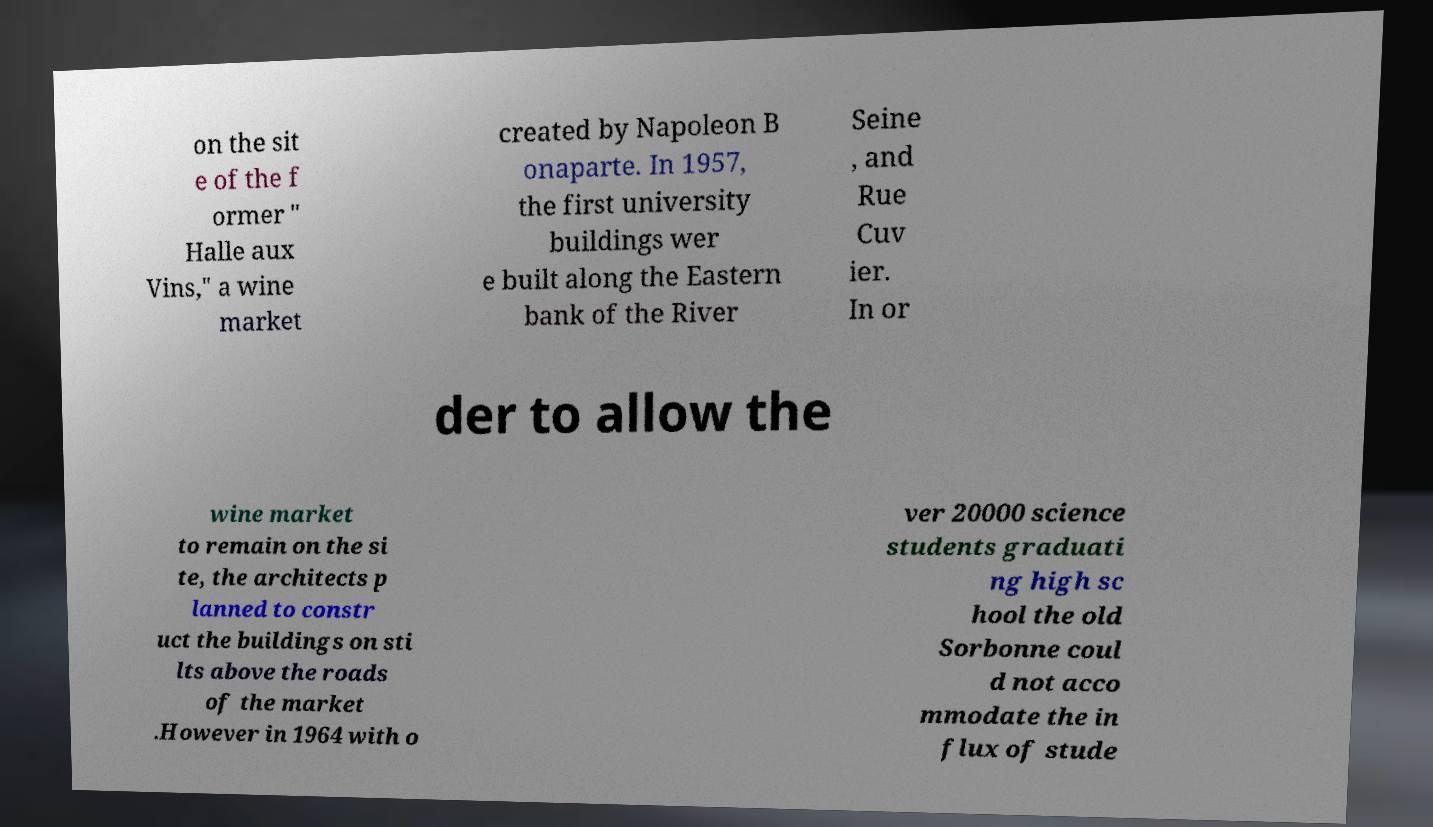What messages or text are displayed in this image? I need them in a readable, typed format. on the sit e of the f ormer " Halle aux Vins," a wine market created by Napoleon B onaparte. In 1957, the first university buildings wer e built along the Eastern bank of the River Seine , and Rue Cuv ier. In or der to allow the wine market to remain on the si te, the architects p lanned to constr uct the buildings on sti lts above the roads of the market .However in 1964 with o ver 20000 science students graduati ng high sc hool the old Sorbonne coul d not acco mmodate the in flux of stude 